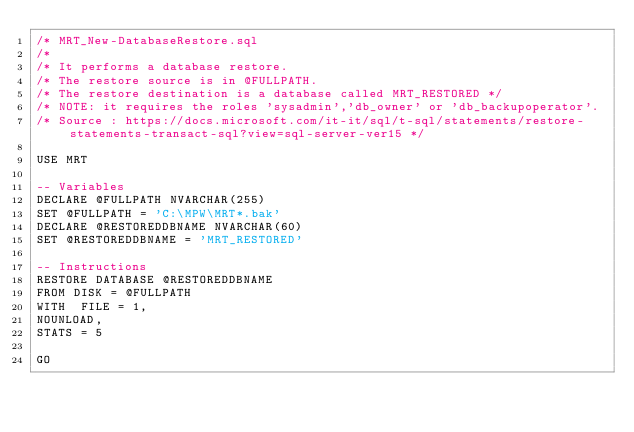Convert code to text. <code><loc_0><loc_0><loc_500><loc_500><_SQL_>/* MRT_New-DatabaseRestore.sql
/*
/* It performs a database restore.
/* The restore source is in @FULLPATH.
/* The restore destination is a database called MRT_RESTORED */
/* NOTE: it requires the roles 'sysadmin','db_owner' or 'db_backupoperator'.
/* Source : https://docs.microsoft.com/it-it/sql/t-sql/statements/restore-statements-transact-sql?view=sql-server-ver15 */

USE MRT

-- Variables
DECLARE @FULLPATH NVARCHAR(255)
SET @FULLPATH = 'C:\MPW\MRT*.bak'
DECLARE @RESTOREDDBNAME NVARCHAR(60)
SET @RESTOREDDBNAME = 'MRT_RESTORED'

-- Instructions
RESTORE DATABASE @RESTOREDDBNAME
FROM DISK = @FULLPATH
WITH  FILE = 1, 
NOUNLOAD,  
STATS = 5

GO
</code> 